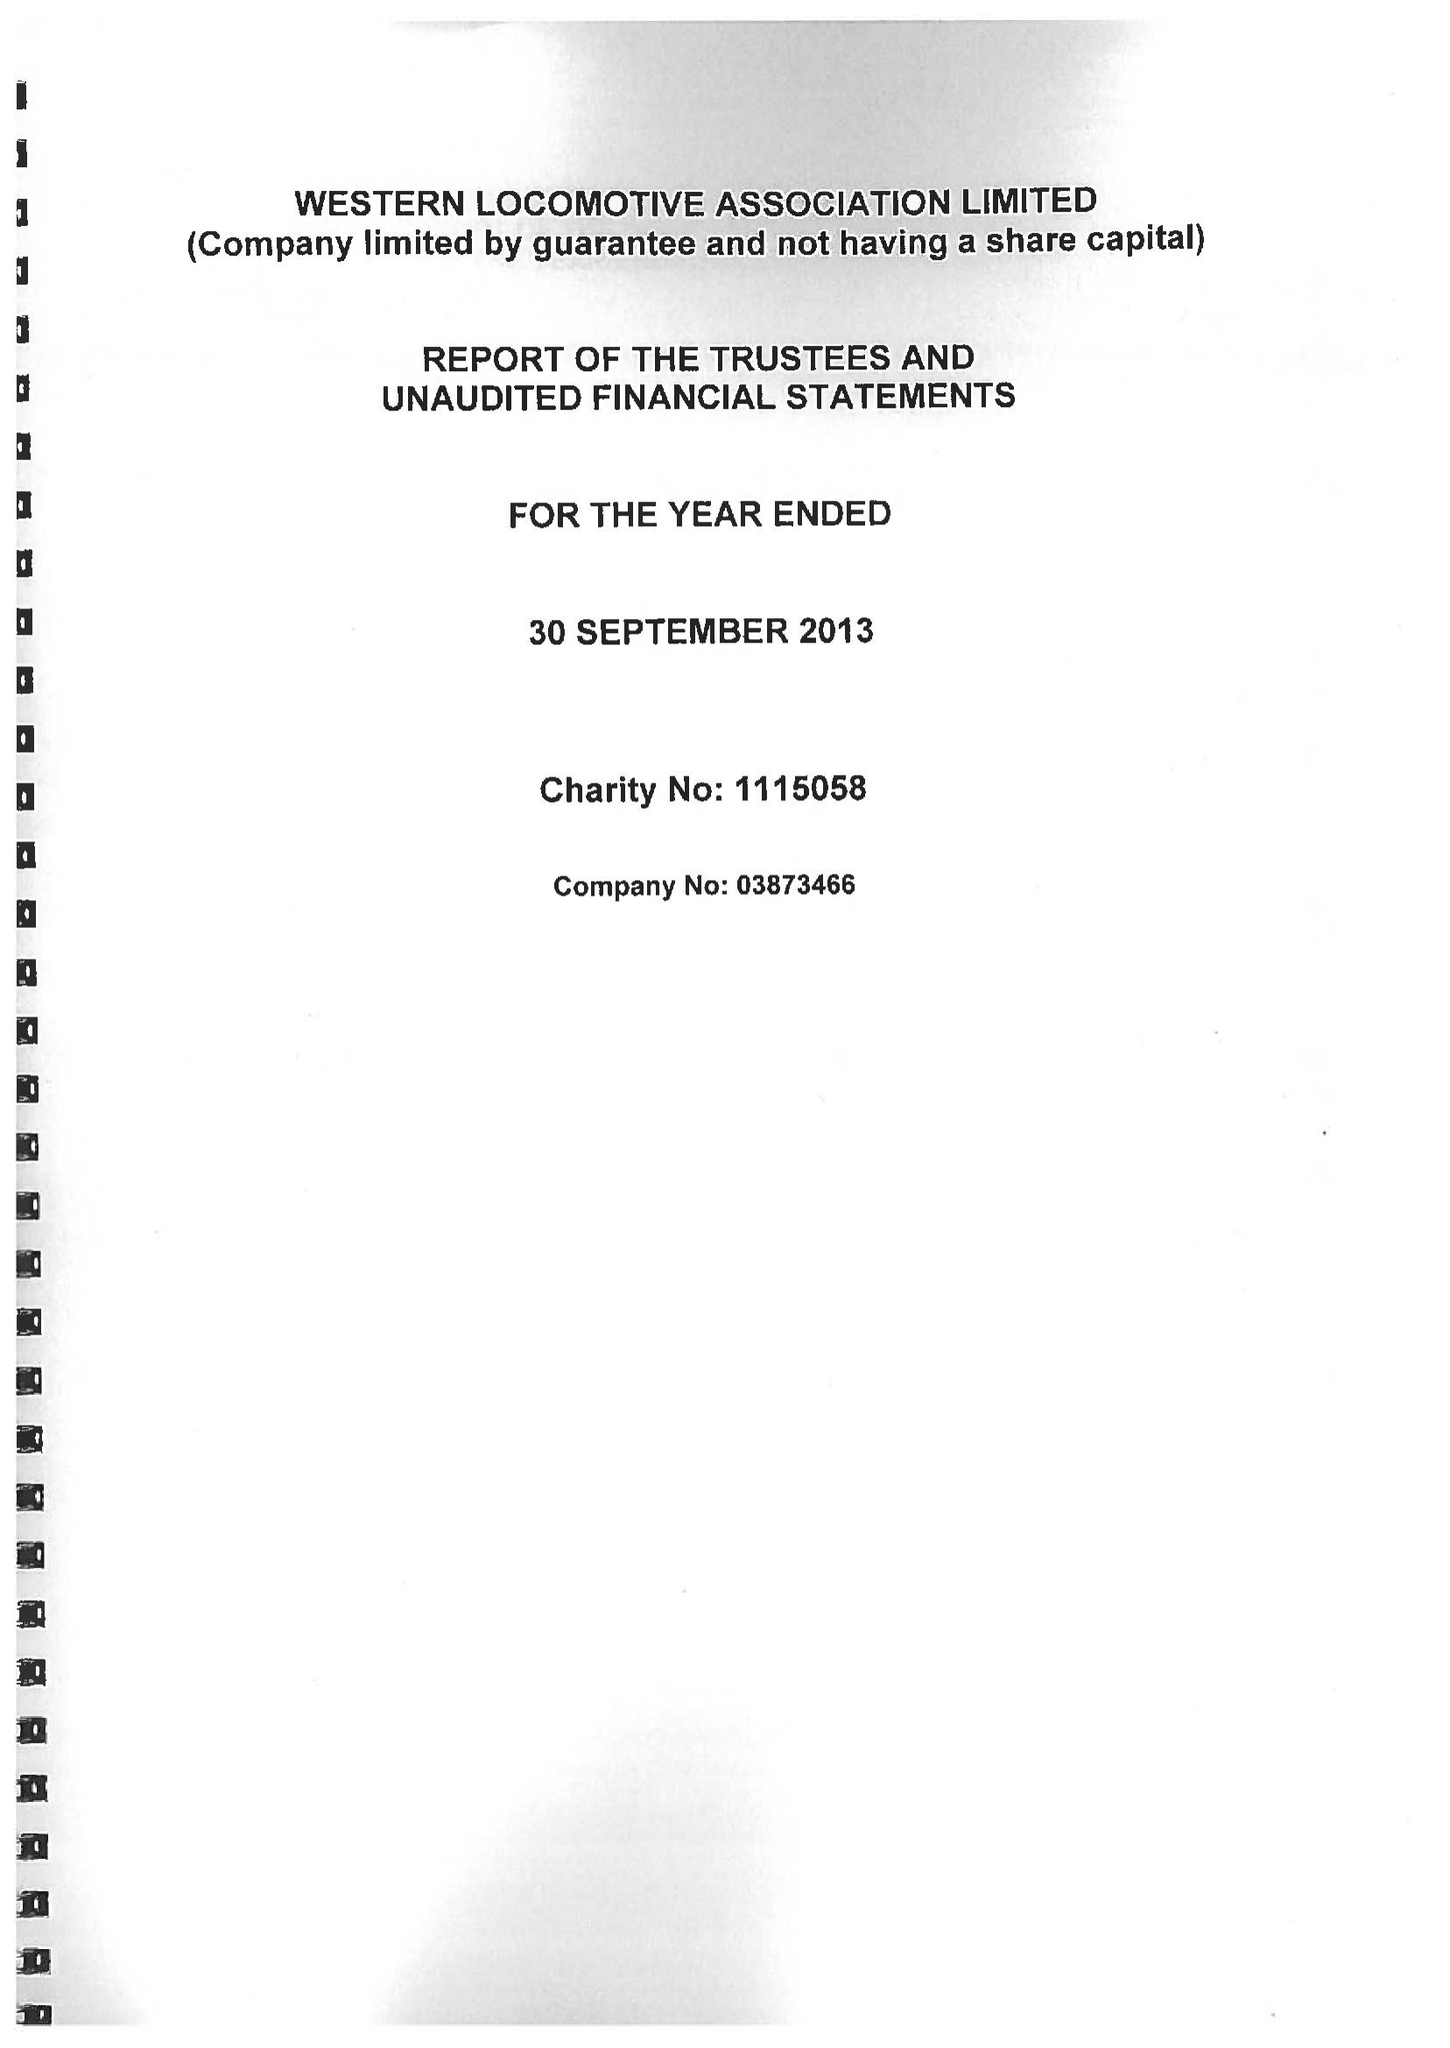What is the value for the report_date?
Answer the question using a single word or phrase. 2013-09-30 